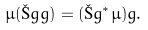<formula> <loc_0><loc_0><loc_500><loc_500>\mu ( \L g g ) = ( \L g ^ { * } \mu ) g .</formula> 